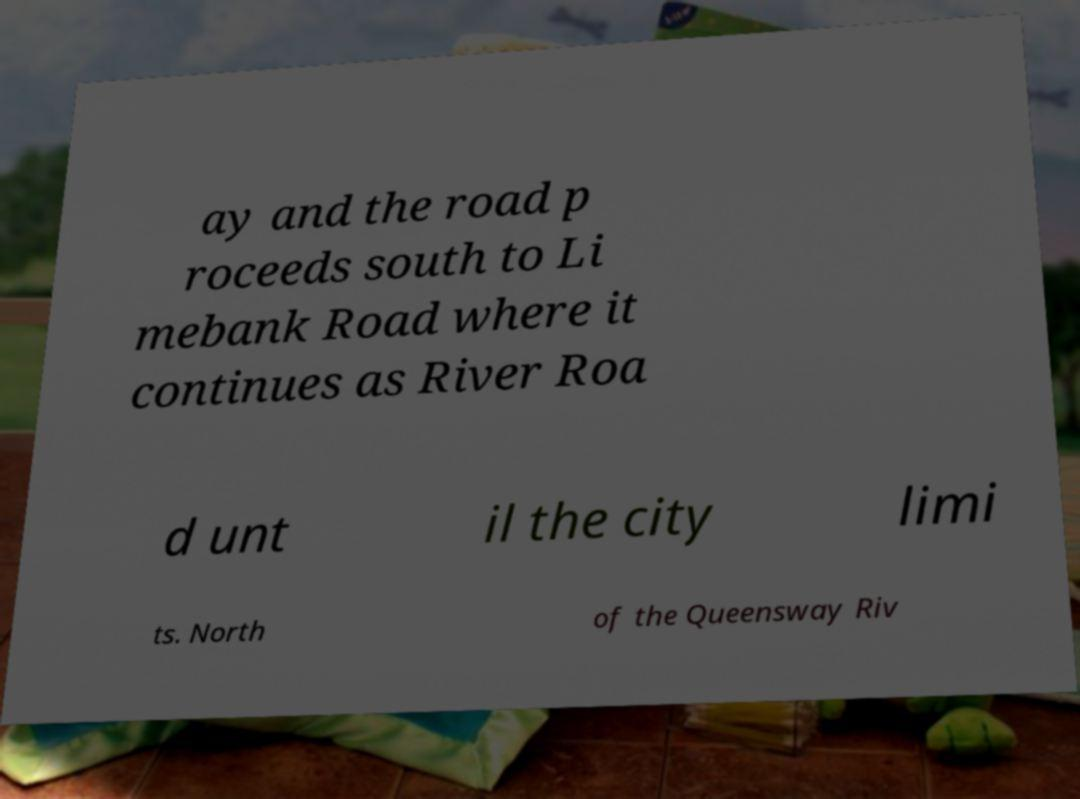Can you read and provide the text displayed in the image?This photo seems to have some interesting text. Can you extract and type it out for me? ay and the road p roceeds south to Li mebank Road where it continues as River Roa d unt il the city limi ts. North of the Queensway Riv 